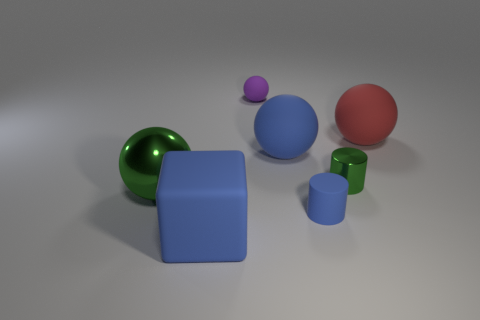Does the big shiny ball have the same color as the tiny ball?
Make the answer very short. No. What material is the blue cube that is in front of the metal thing that is on the right side of the tiny matte thing that is behind the large red rubber thing?
Ensure brevity in your answer.  Rubber. There is a blue rubber block; are there any green metal cylinders in front of it?
Provide a succinct answer. No. What shape is the blue matte object that is the same size as the green metal cylinder?
Make the answer very short. Cylinder. Do the large green object and the small green thing have the same material?
Your answer should be very brief. Yes. What number of matte things are either red things or purple balls?
Give a very brief answer. 2. What is the shape of the large matte object that is the same color as the large cube?
Your answer should be very brief. Sphere. There is a shiny thing in front of the small green thing; does it have the same color as the large matte cube?
Your answer should be compact. No. What shape is the green thing that is behind the large sphere in front of the tiny green metallic cylinder?
Provide a succinct answer. Cylinder. How many things are things in front of the big red ball or small things that are to the right of the small blue object?
Make the answer very short. 5. 